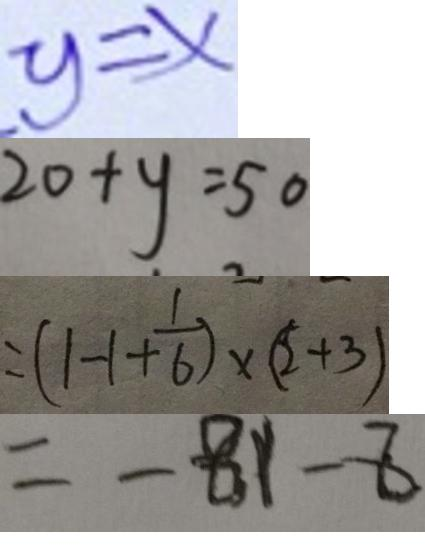Convert formula to latex. <formula><loc_0><loc_0><loc_500><loc_500>y = x 
 2 0 + y = 5 0 
 = ( 1 - 1 + \frac { 1 } { 6 } ) \times ( 2 + 3 ) 
 = - 8 1 - 8</formula> 